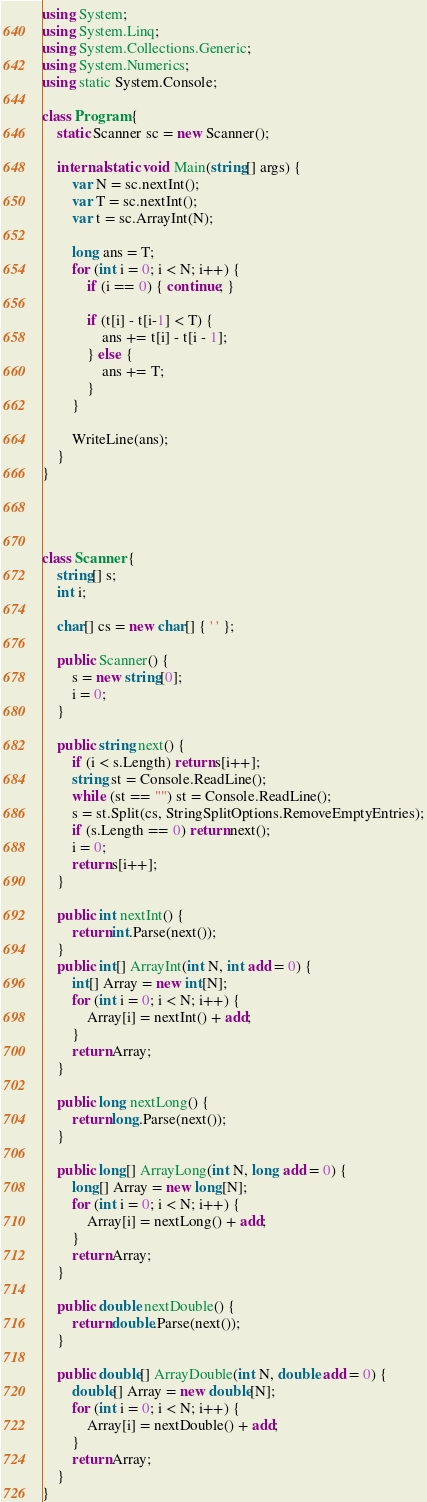Convert code to text. <code><loc_0><loc_0><loc_500><loc_500><_C#_>using System;
using System.Linq;
using System.Collections.Generic;
using System.Numerics;
using static System.Console;

class Program {
    static Scanner sc = new Scanner();

    internal static void Main(string[] args) {
        var N = sc.nextInt();
        var T = sc.nextInt();
        var t = sc.ArrayInt(N);

        long ans = T;
        for (int i = 0; i < N; i++) {
            if (i == 0) { continue; }

            if (t[i] - t[i-1] < T) {
                ans += t[i] - t[i - 1];
            } else {
                ans += T;
            }
        }

        WriteLine(ans);
    }
}




class Scanner {
    string[] s;
    int i;

    char[] cs = new char[] { ' ' };

    public Scanner() {
        s = new string[0];
        i = 0;
    }

    public string next() {
        if (i < s.Length) return s[i++];
        string st = Console.ReadLine();
        while (st == "") st = Console.ReadLine();
        s = st.Split(cs, StringSplitOptions.RemoveEmptyEntries);
        if (s.Length == 0) return next();
        i = 0;
        return s[i++];
    }

    public int nextInt() {
        return int.Parse(next());
    }
    public int[] ArrayInt(int N, int add = 0) {
        int[] Array = new int[N];
        for (int i = 0; i < N; i++) {
            Array[i] = nextInt() + add;
        }
        return Array;
    }

    public long nextLong() {
        return long.Parse(next());
    }

    public long[] ArrayLong(int N, long add = 0) {
        long[] Array = new long[N];
        for (int i = 0; i < N; i++) {
            Array[i] = nextLong() + add;
        }
        return Array;
    }

    public double nextDouble() {
        return double.Parse(next());
    }

    public double[] ArrayDouble(int N, double add = 0) {
        double[] Array = new double[N];
        for (int i = 0; i < N; i++) {
            Array[i] = nextDouble() + add;
        }
        return Array;
    }
}</code> 